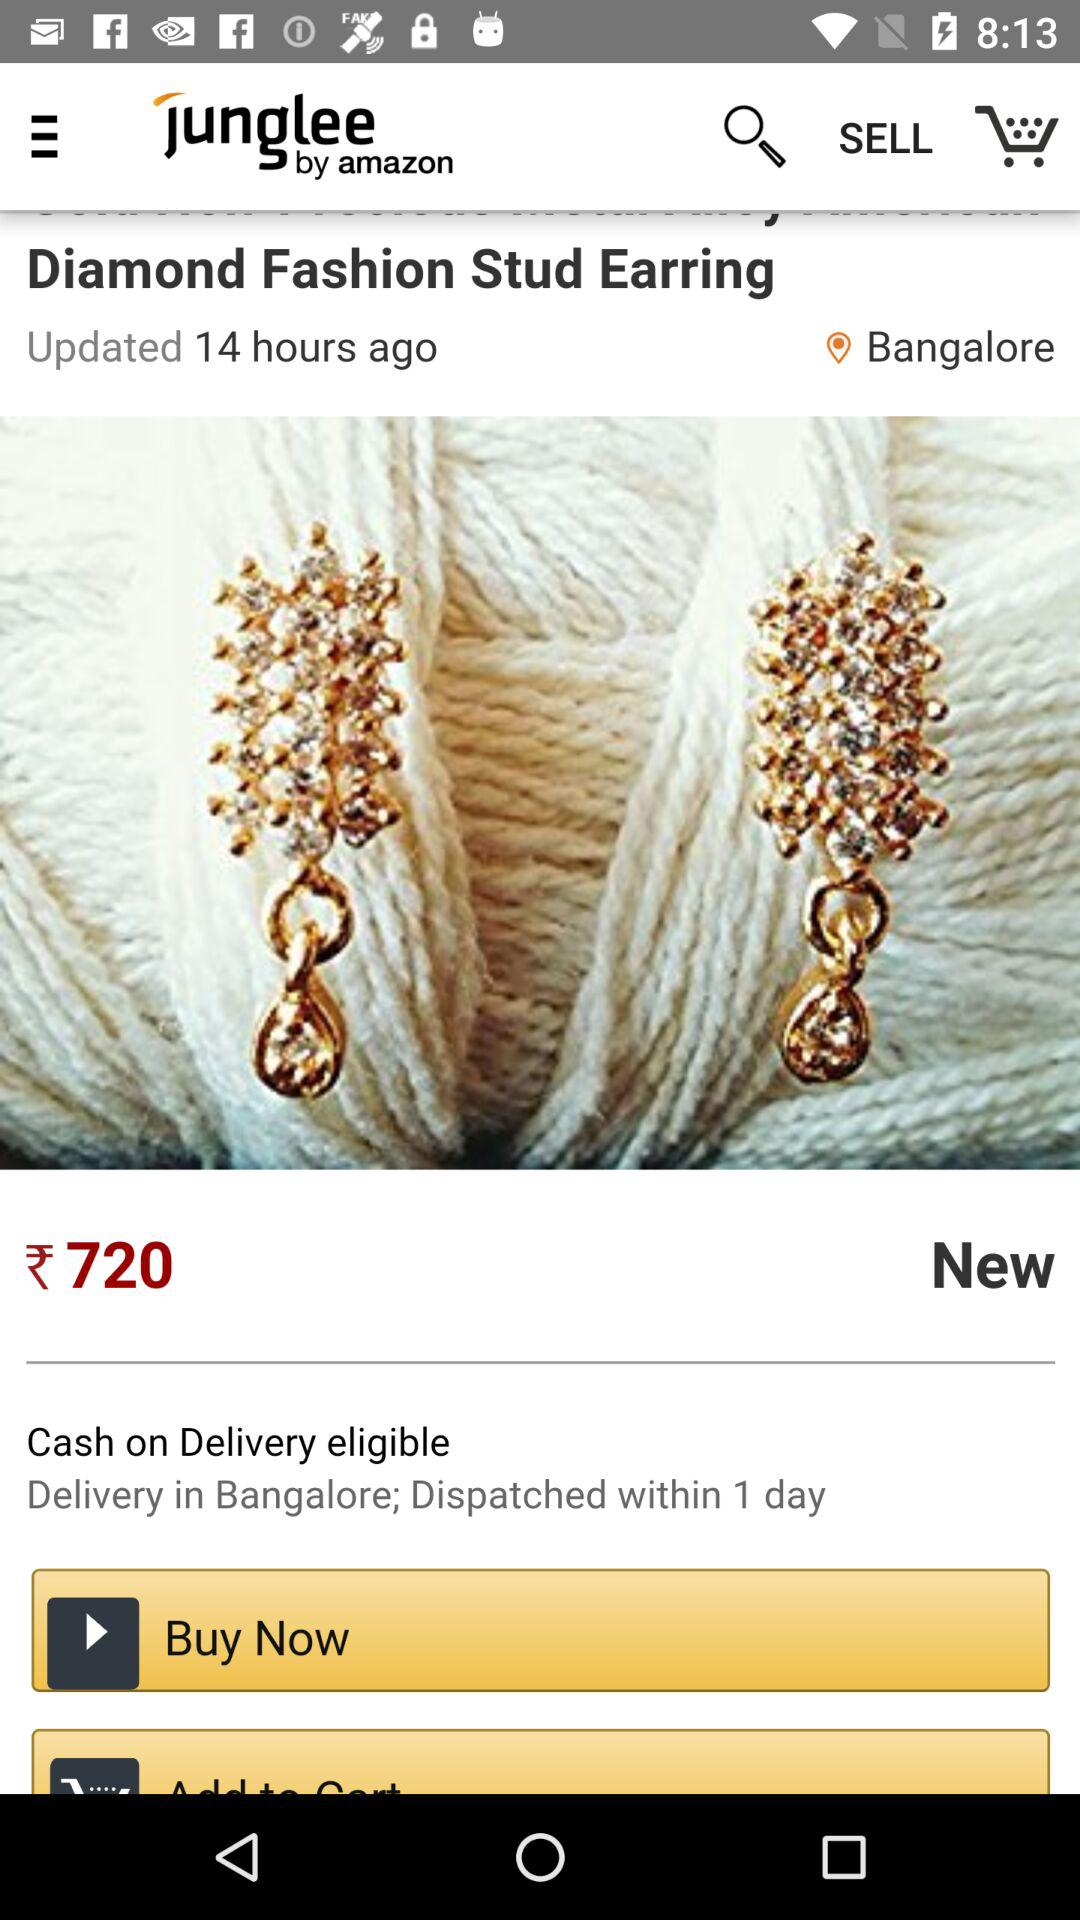What is the location? The location is Bangalore. 